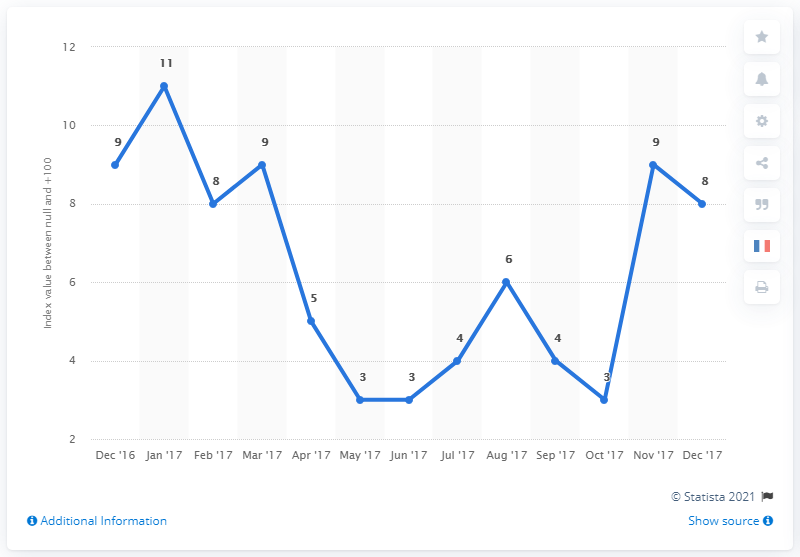Indicate a few pertinent items in this graphic. The economic confidence index of the U.S. population in April 2017 was 5.0. In December 2017, the U.S. Economic Confidence Index was 8. The median value of the Economic Confidence Index from December 2016 to February 2017 was 9. 